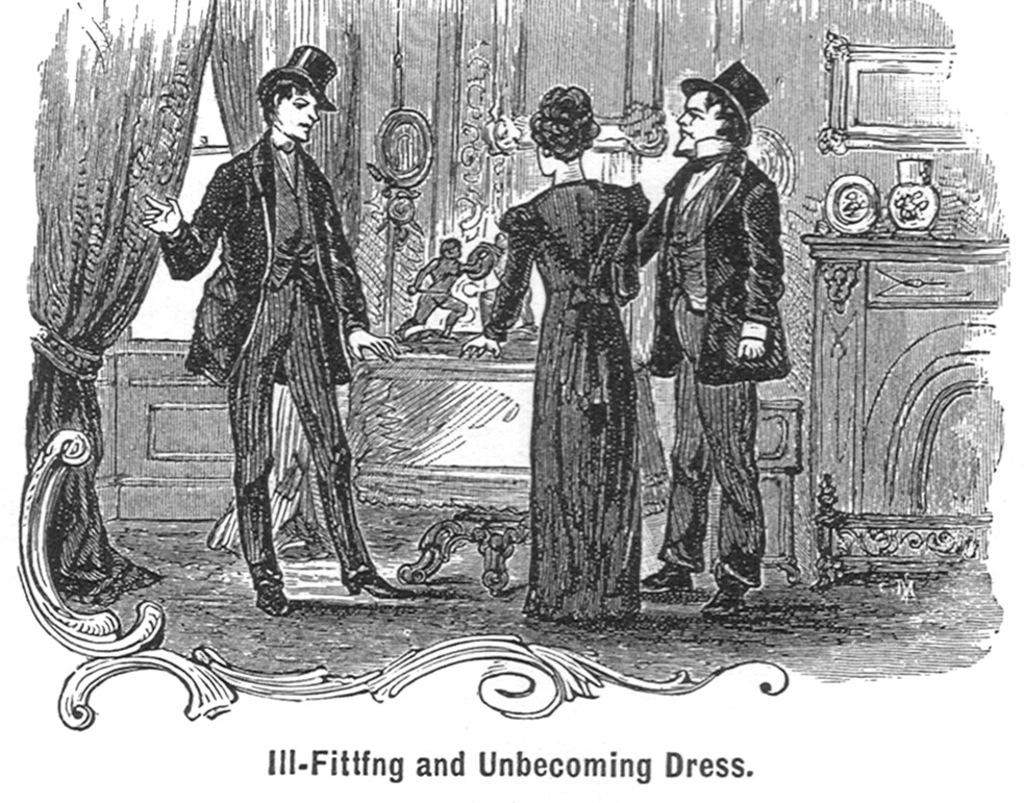What is the main object in the image? There is a poster in the image. What can be seen on the poster? The poster contains images of three people. Is there any text on the poster? Yes, there is text at the bottom of the poster. What color is the juice being served in the image? There is no juice present in the image; it only features a poster with images of three people and text at the bottom. 